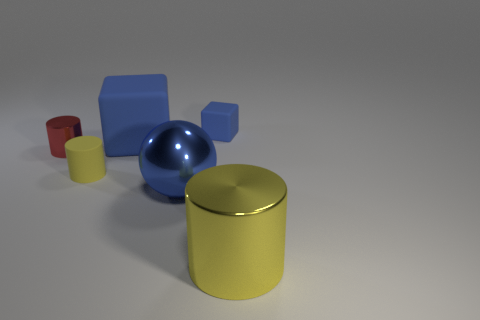Add 1 tiny rubber things. How many objects exist? 7 Subtract all spheres. How many objects are left? 5 Add 5 tiny blue rubber cubes. How many tiny blue rubber cubes are left? 6 Add 5 big rubber things. How many big rubber things exist? 6 Subtract 0 purple blocks. How many objects are left? 6 Subtract all small blue blocks. Subtract all tiny yellow cylinders. How many objects are left? 4 